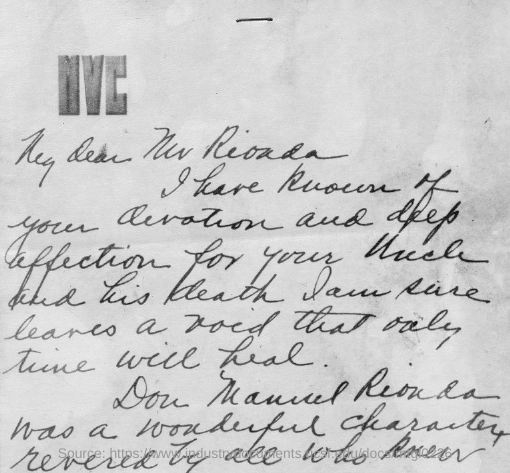Which text is at the top of the document?
Provide a succinct answer. MVC. 